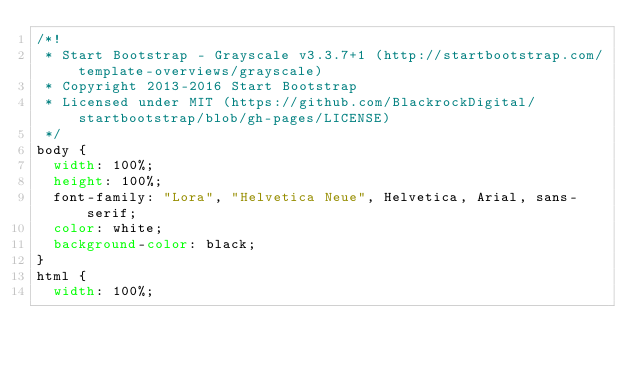Convert code to text. <code><loc_0><loc_0><loc_500><loc_500><_CSS_>/*!
 * Start Bootstrap - Grayscale v3.3.7+1 (http://startbootstrap.com/template-overviews/grayscale)
 * Copyright 2013-2016 Start Bootstrap
 * Licensed under MIT (https://github.com/BlackrockDigital/startbootstrap/blob/gh-pages/LICENSE)
 */
body {
  width: 100%;
  height: 100%;
  font-family: "Lora", "Helvetica Neue", Helvetica, Arial, sans-serif;
  color: white;
  background-color: black;
}
html {
  width: 100%;</code> 